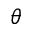<formula> <loc_0><loc_0><loc_500><loc_500>\theta</formula> 